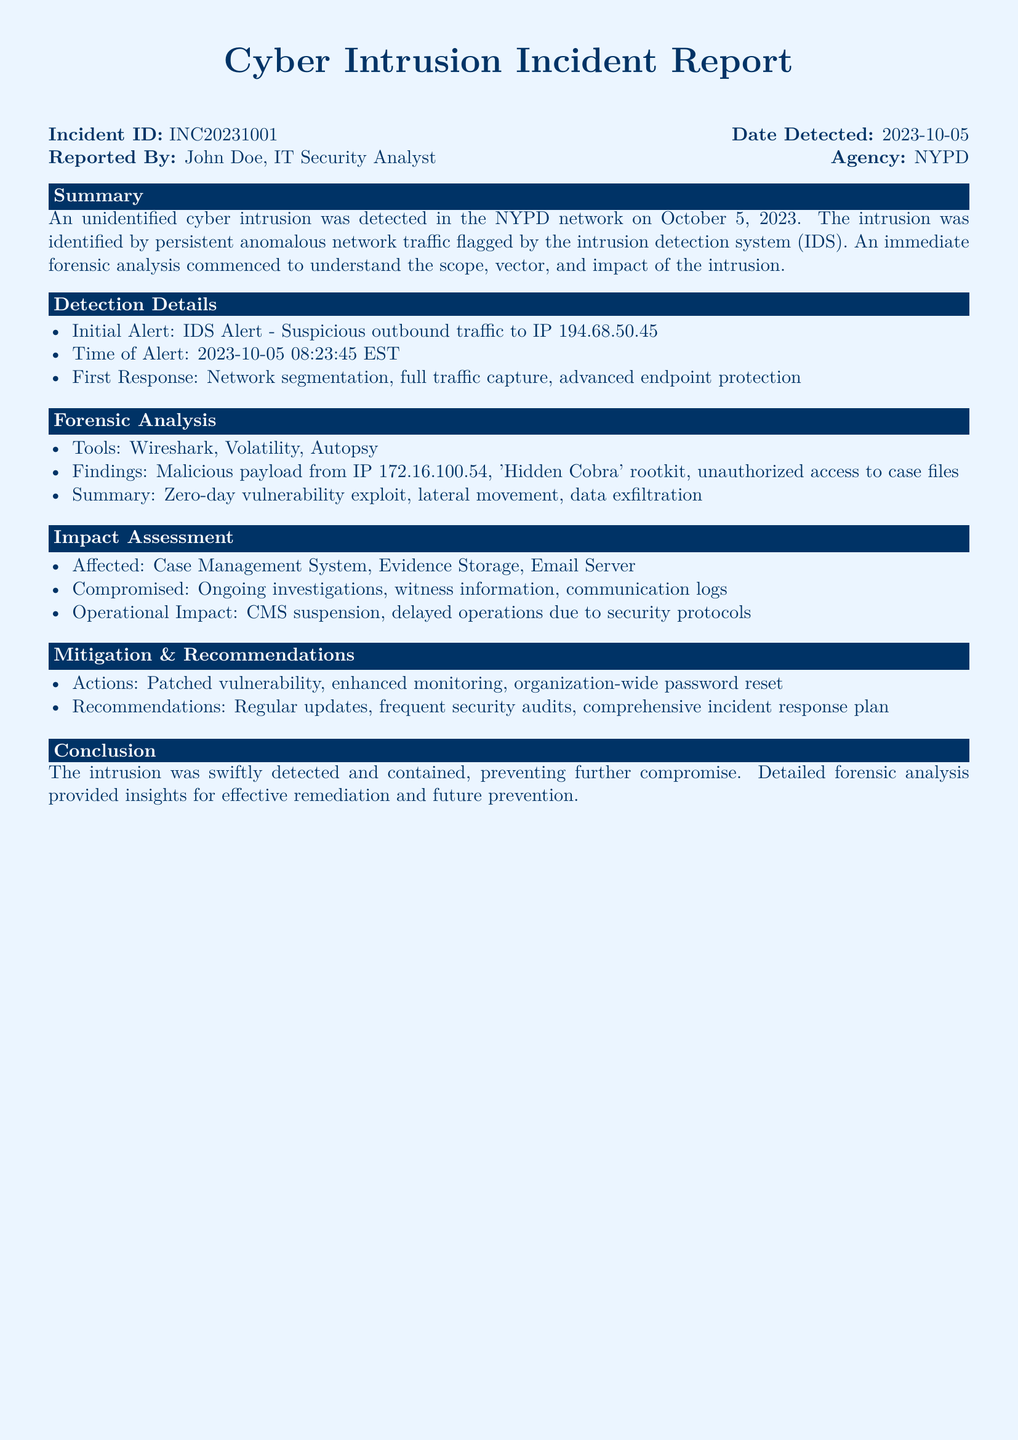What is the Incident ID? The Incident ID is a unique identifier for the incident within the report.
Answer: INC20231001 Who reported the incident? The individual responsible for reporting the incident is noted in the document.
Answer: John Doe What was the date the intrusion was detected? The date of detection provides context for when the event occurred.
Answer: 2023-10-05 What was the initial alert? This describes the first indication of the cyber intrusion as per the incident report.
Answer: IDS Alert - Suspicious outbound traffic to IP 194.68.50.45 Which tools were used for forensic analysis? The tools listed help understand the methods utilized in the investigation of the intrusion.
Answer: Wireshark, Volatility, Autopsy What type of rootkit was identified? This information highlights the specific malicious software detected during the analysis.
Answer: 'Hidden Cobra' rootkit What areas were affected by the intrusion? Identifying the systems impacted helps assess the severity of the incident.
Answer: Case Management System, Evidence Storage, Email Server What actions were taken to mitigate the incident? The document notes specific measures implemented in response to the detection.
Answer: Patched vulnerability, enhanced monitoring, organization-wide password reset What is one recommended action for future prevention? This highlights proactive measures suggested to avoid similar incidents in the future.
Answer: Regular updates 